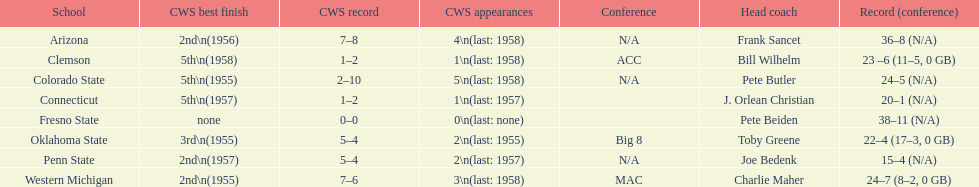Does clemson or western michigan have more cws appearances? Western Michigan. Would you be able to parse every entry in this table? {'header': ['School', 'CWS best finish', 'CWS record', 'CWS appearances', 'Conference', 'Head coach', 'Record (conference)'], 'rows': [['Arizona', '2nd\\n(1956)', '7–8', '4\\n(last: 1958)', 'N/A', 'Frank Sancet', '36–8 (N/A)'], ['Clemson', '5th\\n(1958)', '1–2', '1\\n(last: 1958)', 'ACC', 'Bill Wilhelm', '23 –6 (11–5, 0 GB)'], ['Colorado State', '5th\\n(1955)', '2–10', '5\\n(last: 1958)', 'N/A', 'Pete Butler', '24–5 (N/A)'], ['Connecticut', '5th\\n(1957)', '1–2', '1\\n(last: 1957)', '', 'J. Orlean Christian', '20–1 (N/A)'], ['Fresno State', 'none', '0–0', '0\\n(last: none)', '', 'Pete Beiden', '38–11 (N/A)'], ['Oklahoma State', '3rd\\n(1955)', '5–4', '2\\n(last: 1955)', 'Big 8', 'Toby Greene', '22–4 (17–3, 0 GB)'], ['Penn State', '2nd\\n(1957)', '5–4', '2\\n(last: 1957)', 'N/A', 'Joe Bedenk', '15–4 (N/A)'], ['Western Michigan', '2nd\\n(1955)', '7–6', '3\\n(last: 1958)', 'MAC', 'Charlie Maher', '24–7 (8–2, 0 GB)']]} 